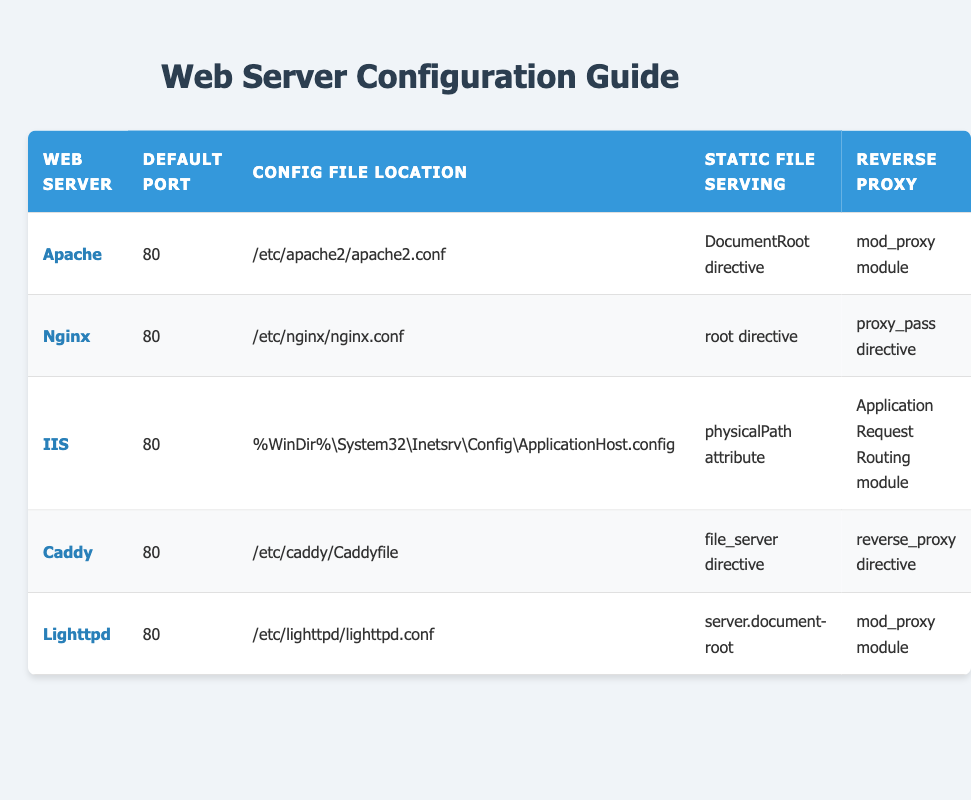What is the default port for Apache? The default port for Apache is directly listed under the "Default Port" column in the row corresponding to Apache.
Answer: 80 Which web server uses the "reverse_proxy" directive for reverse proxy configuration? The directive "reverse_proxy" is mentioned in the row for Caddy under the "Reverse Proxy" column.
Answer: Caddy Is IIS configured to serve static files using a "DocumentRoot" directive? The "DocumentRoot" directive is specific to Apache, and in the row for IIS, the static file serving is indicated by the "physicalPath" attribute. Thus, IIS does not use the "DocumentRoot" directive.
Answer: No What configuration files are used for Nginx and Lighttpd? The configuration file for Nginx is found under its row as "/etc/nginx/nginx.conf" and for Lighttpd, it is "/etc/lighttpd/lighttpd.conf".
Answer: /etc/nginx/nginx.conf and /etc/lighttpd/lighttpd.conf Which web server has the configuration file located at "%WinDir%\System32\Inetsrv\Config\ApplicationHost.config"? This configuration file location is mentioned under the row for IIS, which can be directly referenced.
Answer: IIS What do Apache and Lighttpd have in common regarding reverse proxy configuration? Both Apache and Lighttpd utilize the "mod_proxy" module for their reverse proxy configuration, as specified in their respective rows under the "Reverse Proxy" column.
Answer: They both use the mod_proxy module What web server has the "root directive" for static file serving, and what is its default port? The web server with the "root directive" for static file serving is Nginx, which also has a default port of 80, as indicated in the appropriate columns for Nginx.
Answer: Nginx, 80 Is it true that all web servers listed use port 80 as their default port? By examining the "Default Port" column, every listed web server (Apache, Nginx, IIS, Caddy, Lighttpd) is shown to use 80 as the default port, confirming the statement is true.
Answer: Yes Which web server uses a "file_server" directive for static file serving, and how does it differ from the serving methods of other web servers? The web server that uses the "file_server" directive for static file serving is Caddy. It differs from the serving methods of other web servers by using a specific directive, while others like Apache and Lighttpd use the "DocumentRoot" and "server.document-root" respectively.
Answer: Caddy; it uses "file_server" directive 